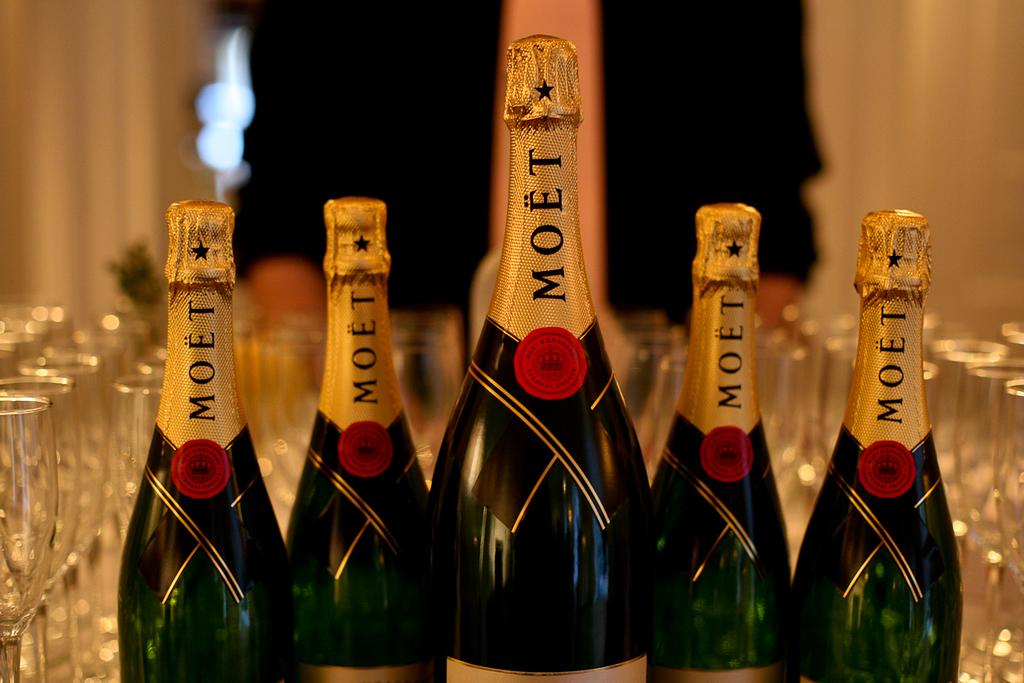What kind of champagne is that?
Offer a very short reply. Moet. What letter is closest to the top of the bottles?
Your response must be concise. T. 